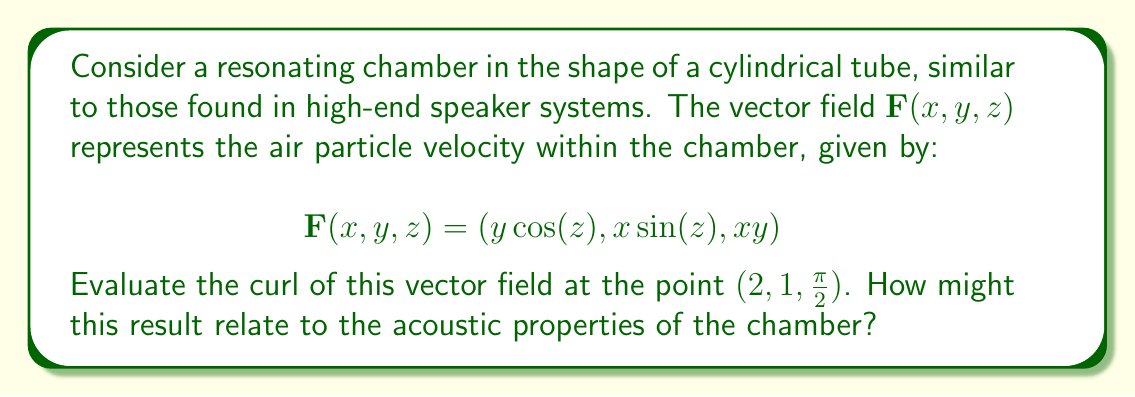Can you solve this math problem? Let's approach this step-by-step:

1) The curl of a vector field $\mathbf{F}(x,y,z) = (F_x, F_y, F_z)$ is defined as:

   $$\text{curl }\mathbf{F} = \nabla \times \mathbf{F} = \left(\frac{\partial F_z}{\partial y} - \frac{\partial F_y}{\partial z}, \frac{\partial F_x}{\partial z} - \frac{\partial F_z}{\partial x}, \frac{\partial F_y}{\partial x} - \frac{\partial F_x}{\partial y}\right)$$

2) For our vector field:
   $F_x = y\cos(z)$
   $F_y = x\sin(z)$
   $F_z = xy$

3) Let's calculate each component:

   $\frac{\partial F_z}{\partial y} = x$
   $\frac{\partial F_y}{\partial z} = x\cos(z)$
   $\frac{\partial F_x}{\partial z} = -y\sin(z)$
   $\frac{\partial F_z}{\partial x} = y$
   $\frac{\partial F_y}{\partial x} = \sin(z)$
   $\frac{\partial F_x}{\partial y} = \cos(z)$

4) Now, we can form the curl:

   $$\text{curl }\mathbf{F} = (x - x\cos(z), -y\sin(z) - y, \sin(z) - \cos(z))$$

5) Evaluating at the point $(2, 1, \frac{\pi}{2})$:

   $$\text{curl }\mathbf{F}(2, 1, \frac{\pi}{2}) = (2 - 2\cos(\frac{\pi}{2}), -\sin(\frac{\pi}{2}) - 1, \sin(\frac{\pi}{2}) - \cos(\frac{\pi}{2}))$$

6) Simplifying:

   $$\text{curl }\mathbf{F}(2, 1, \frac{\pi}{2}) = (2, -2, 1)$$

This result indicates a non-zero curl, suggesting rotational motion of air particles at this point. In the context of acoustics, this could relate to the formation of vortices or eddies in the air flow, potentially affecting the sound quality or resonance characteristics of the chamber. The specific values might influence the timbre or overtones produced in this part of the speaker system.
Answer: $(2, -2, 1)$ 